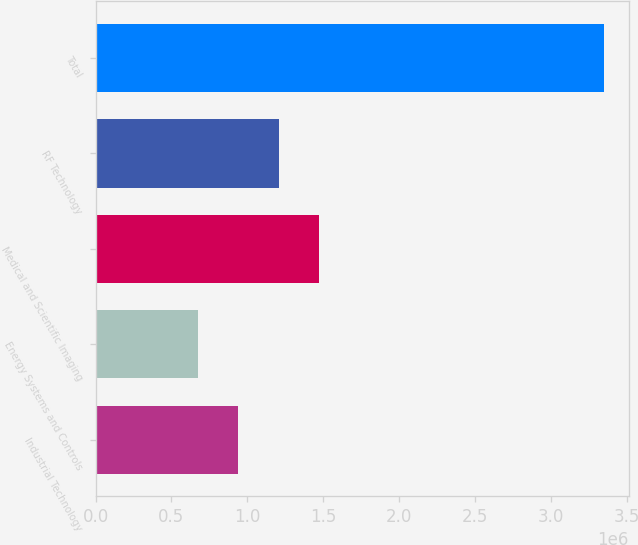<chart> <loc_0><loc_0><loc_500><loc_500><bar_chart><fcel>Industrial Technology<fcel>Energy Systems and Controls<fcel>Medical and Scientific Imaging<fcel>RF Technology<fcel>Total<nl><fcel>941061<fcel>673569<fcel>1.47605e+06<fcel>1.20855e+06<fcel>3.34849e+06<nl></chart> 